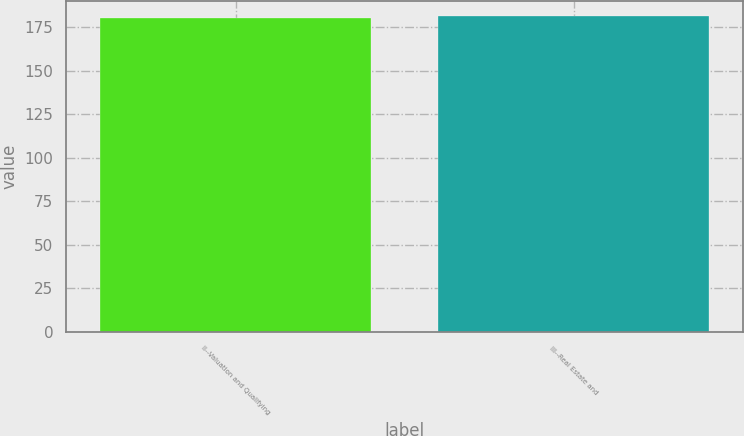<chart> <loc_0><loc_0><loc_500><loc_500><bar_chart><fcel>II--Valuation and Qualifying<fcel>III--Real Estate and<nl><fcel>180<fcel>181<nl></chart> 